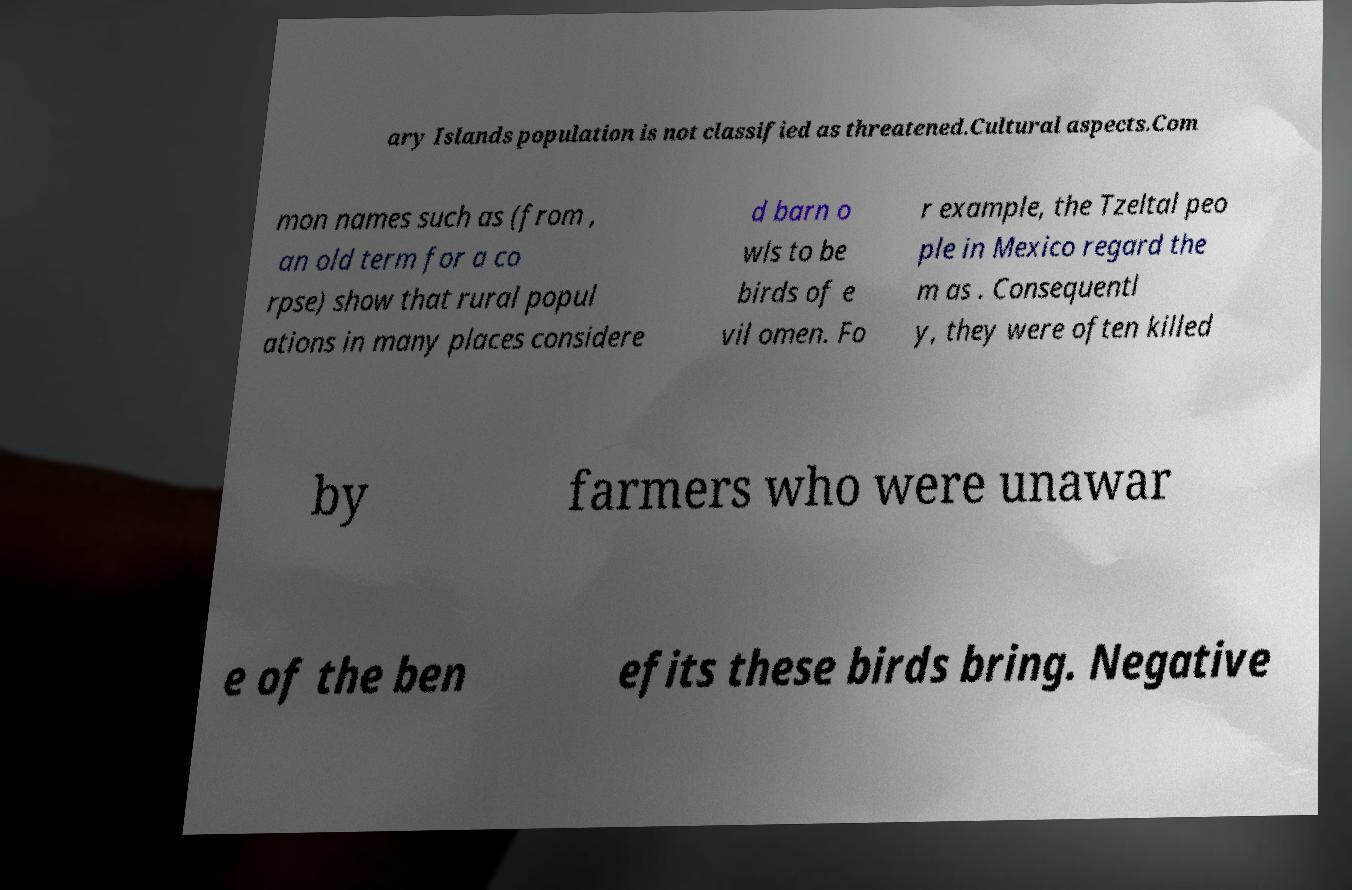Please identify and transcribe the text found in this image. ary Islands population is not classified as threatened.Cultural aspects.Com mon names such as (from , an old term for a co rpse) show that rural popul ations in many places considere d barn o wls to be birds of e vil omen. Fo r example, the Tzeltal peo ple in Mexico regard the m as . Consequentl y, they were often killed by farmers who were unawar e of the ben efits these birds bring. Negative 